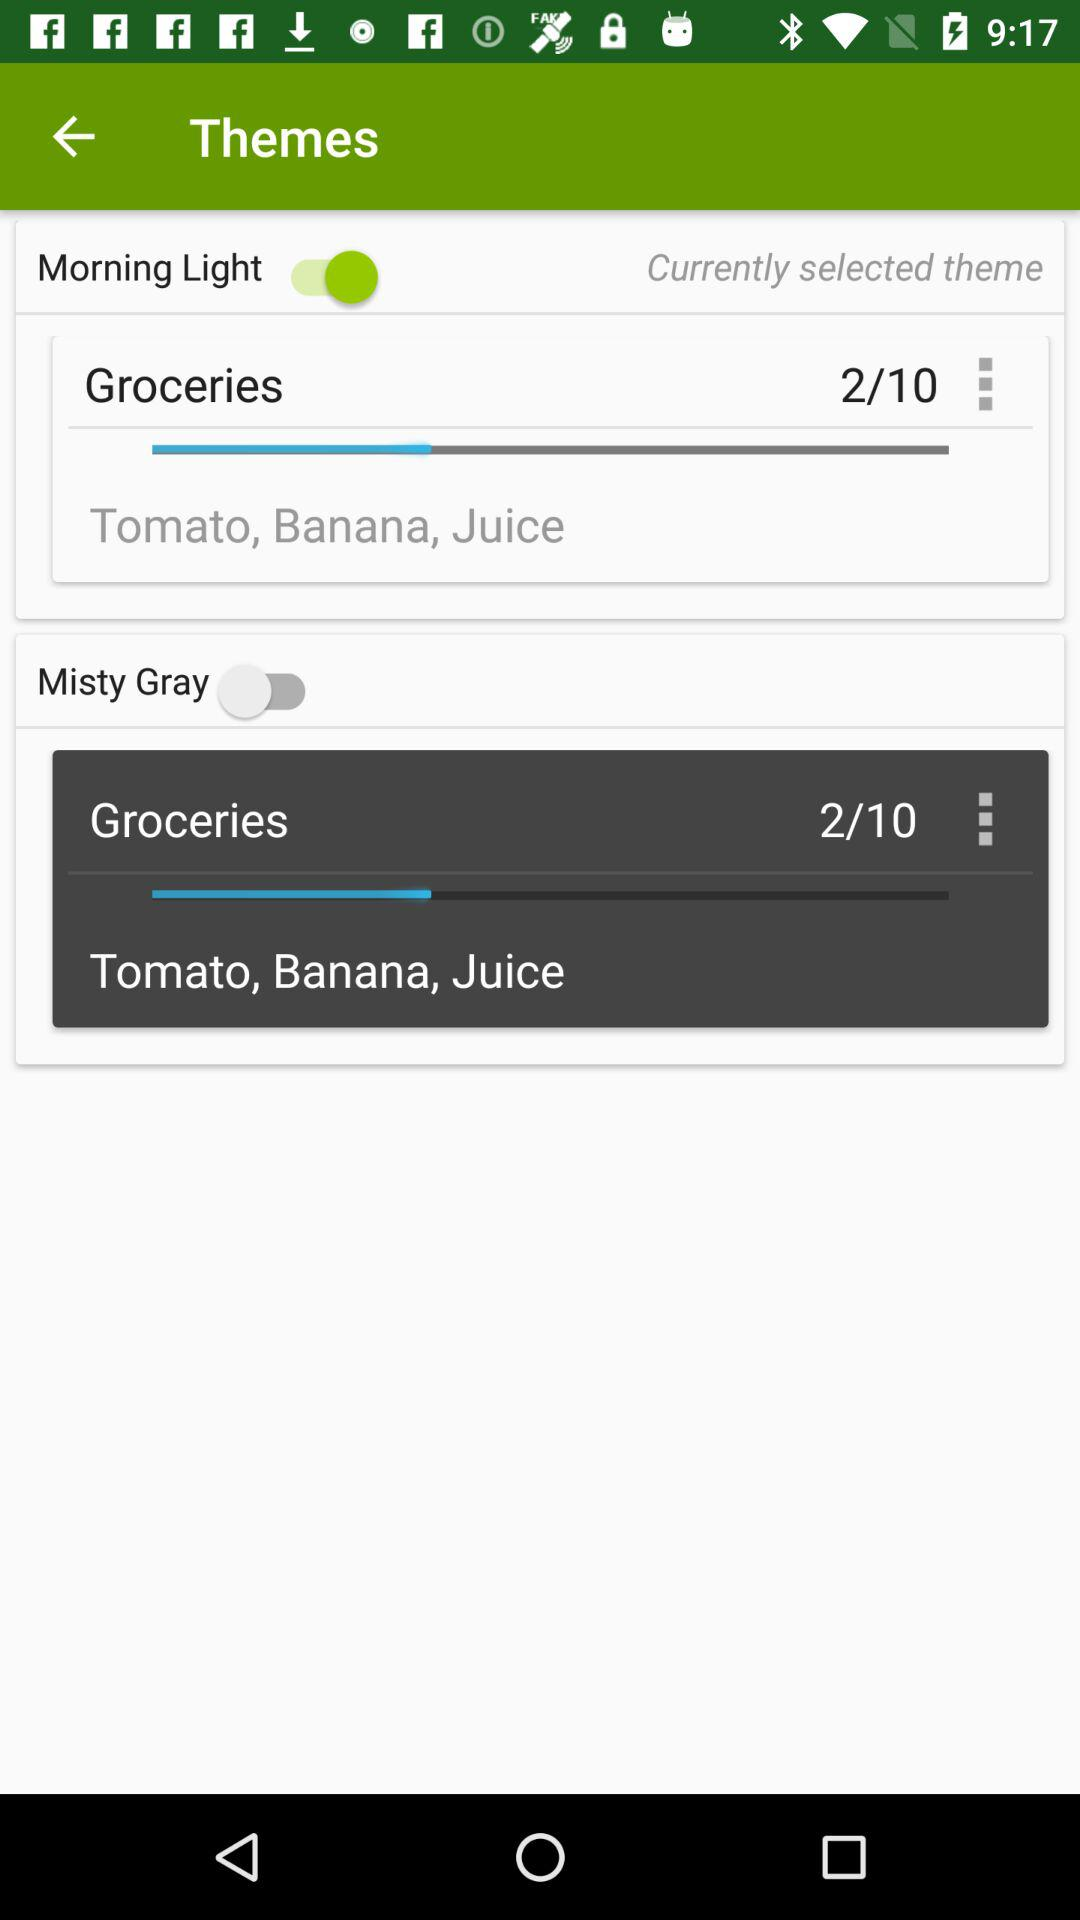What is the status of "Morning Light"? The status is "on". 